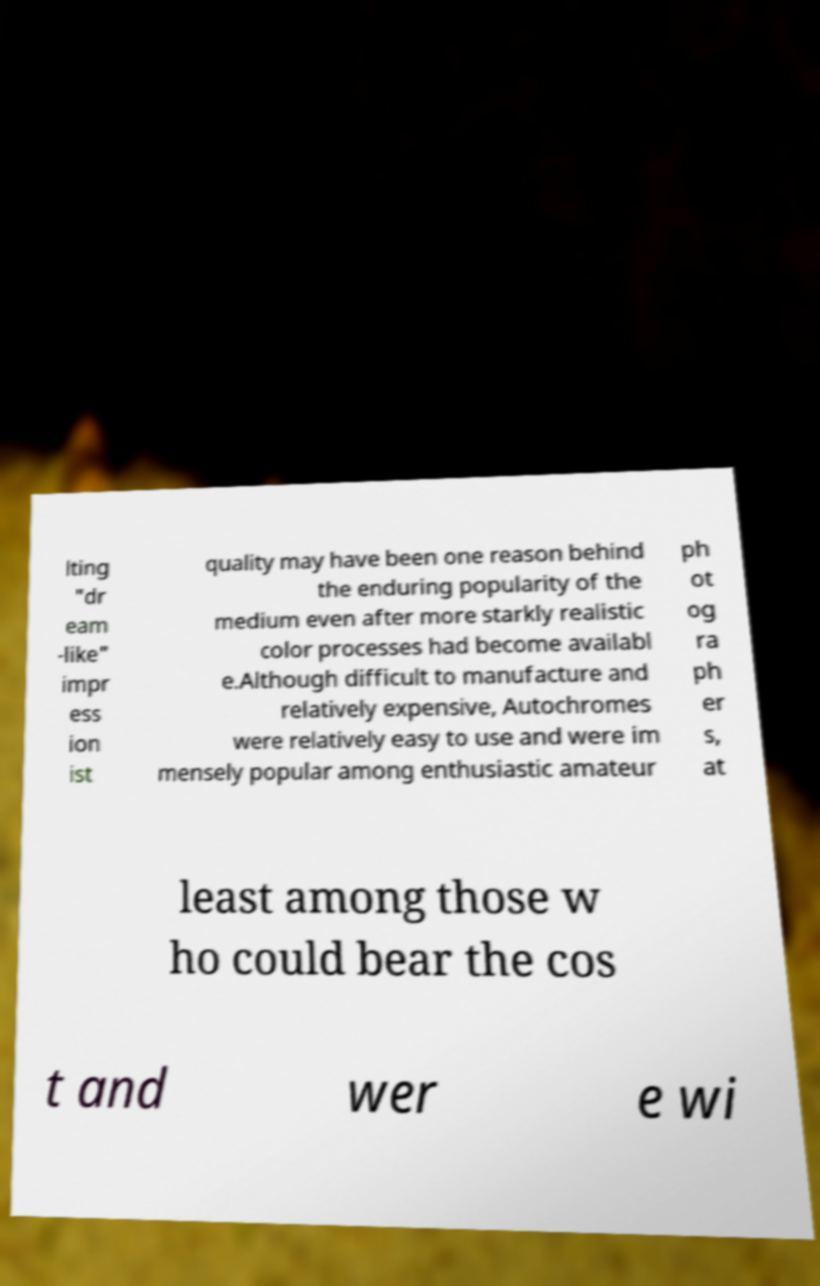For documentation purposes, I need the text within this image transcribed. Could you provide that? lting "dr eam -like" impr ess ion ist quality may have been one reason behind the enduring popularity of the medium even after more starkly realistic color processes had become availabl e.Although difficult to manufacture and relatively expensive, Autochromes were relatively easy to use and were im mensely popular among enthusiastic amateur ph ot og ra ph er s, at least among those w ho could bear the cos t and wer e wi 